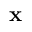Convert formula to latex. <formula><loc_0><loc_0><loc_500><loc_500>x</formula> 